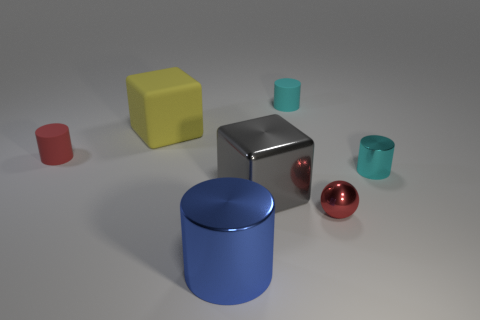Subtract 1 cylinders. How many cylinders are left? 3 Subtract all cyan spheres. Subtract all purple blocks. How many spheres are left? 1 Add 3 big gray metallic balls. How many objects exist? 10 Subtract all cylinders. How many objects are left? 3 Add 4 big metal blocks. How many big metal blocks exist? 5 Subtract 1 blue cylinders. How many objects are left? 6 Subtract all large gray metallic blocks. Subtract all rubber blocks. How many objects are left? 5 Add 7 big matte cubes. How many big matte cubes are left? 8 